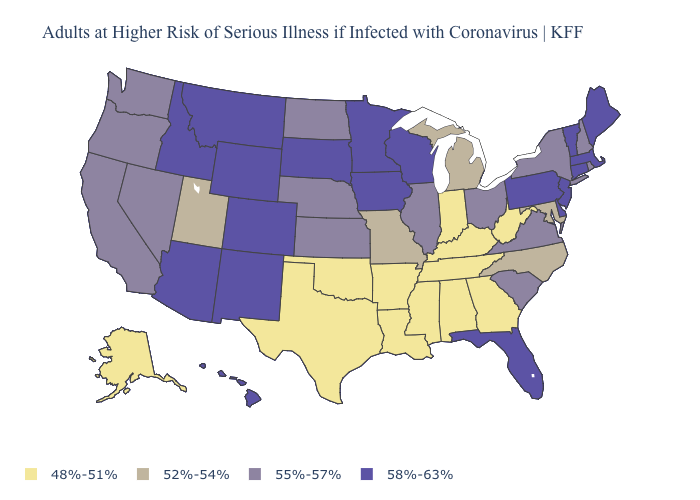What is the value of Florida?
Keep it brief. 58%-63%. What is the value of New Mexico?
Keep it brief. 58%-63%. Does the first symbol in the legend represent the smallest category?
Be succinct. Yes. Does Connecticut have a higher value than New York?
Be succinct. Yes. Among the states that border Tennessee , which have the highest value?
Answer briefly. Virginia. What is the value of Wyoming?
Be succinct. 58%-63%. Name the states that have a value in the range 48%-51%?
Short answer required. Alabama, Alaska, Arkansas, Georgia, Indiana, Kentucky, Louisiana, Mississippi, Oklahoma, Tennessee, Texas, West Virginia. Does the map have missing data?
Write a very short answer. No. What is the highest value in states that border Vermont?
Quick response, please. 58%-63%. Does Indiana have the lowest value in the MidWest?
Keep it brief. Yes. What is the value of North Dakota?
Be succinct. 55%-57%. What is the value of Virginia?
Answer briefly. 55%-57%. Which states have the highest value in the USA?
Write a very short answer. Arizona, Colorado, Connecticut, Delaware, Florida, Hawaii, Idaho, Iowa, Maine, Massachusetts, Minnesota, Montana, New Jersey, New Mexico, Pennsylvania, South Dakota, Vermont, Wisconsin, Wyoming. Does Alaska have the lowest value in the West?
Give a very brief answer. Yes. 